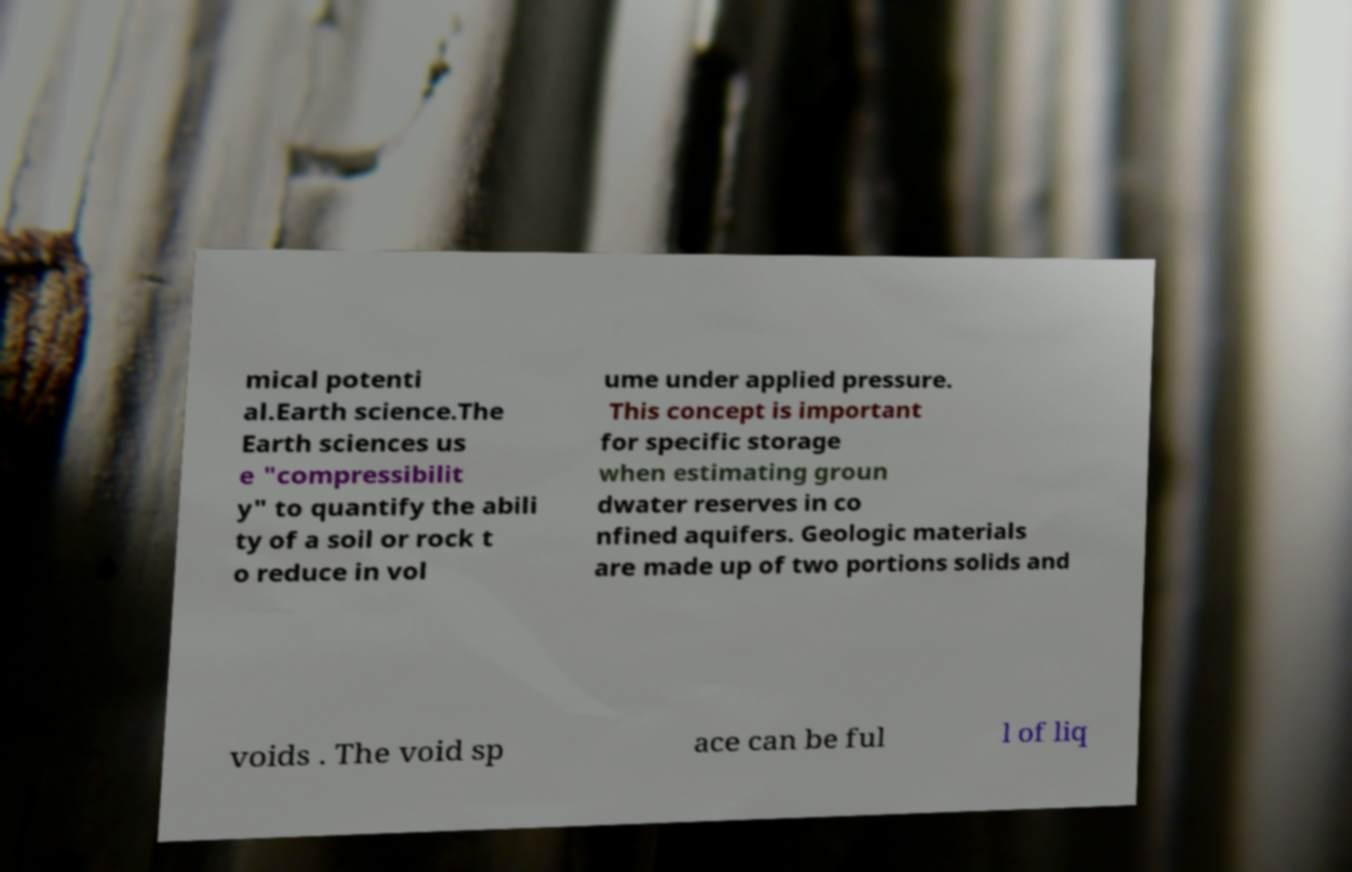What messages or text are displayed in this image? I need them in a readable, typed format. mical potenti al.Earth science.The Earth sciences us e "compressibilit y" to quantify the abili ty of a soil or rock t o reduce in vol ume under applied pressure. This concept is important for specific storage when estimating groun dwater reserves in co nfined aquifers. Geologic materials are made up of two portions solids and voids . The void sp ace can be ful l of liq 